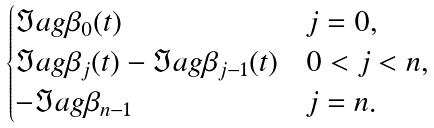<formula> <loc_0><loc_0><loc_500><loc_500>\begin{cases} \Im a g \beta _ { 0 } ( t ) & j = 0 , \\ \Im a g \beta _ { j } ( t ) - \Im a g \beta _ { j - 1 } ( t ) & 0 < j < n , \\ - \Im a g \beta _ { n - 1 } & j = n . \end{cases}</formula> 